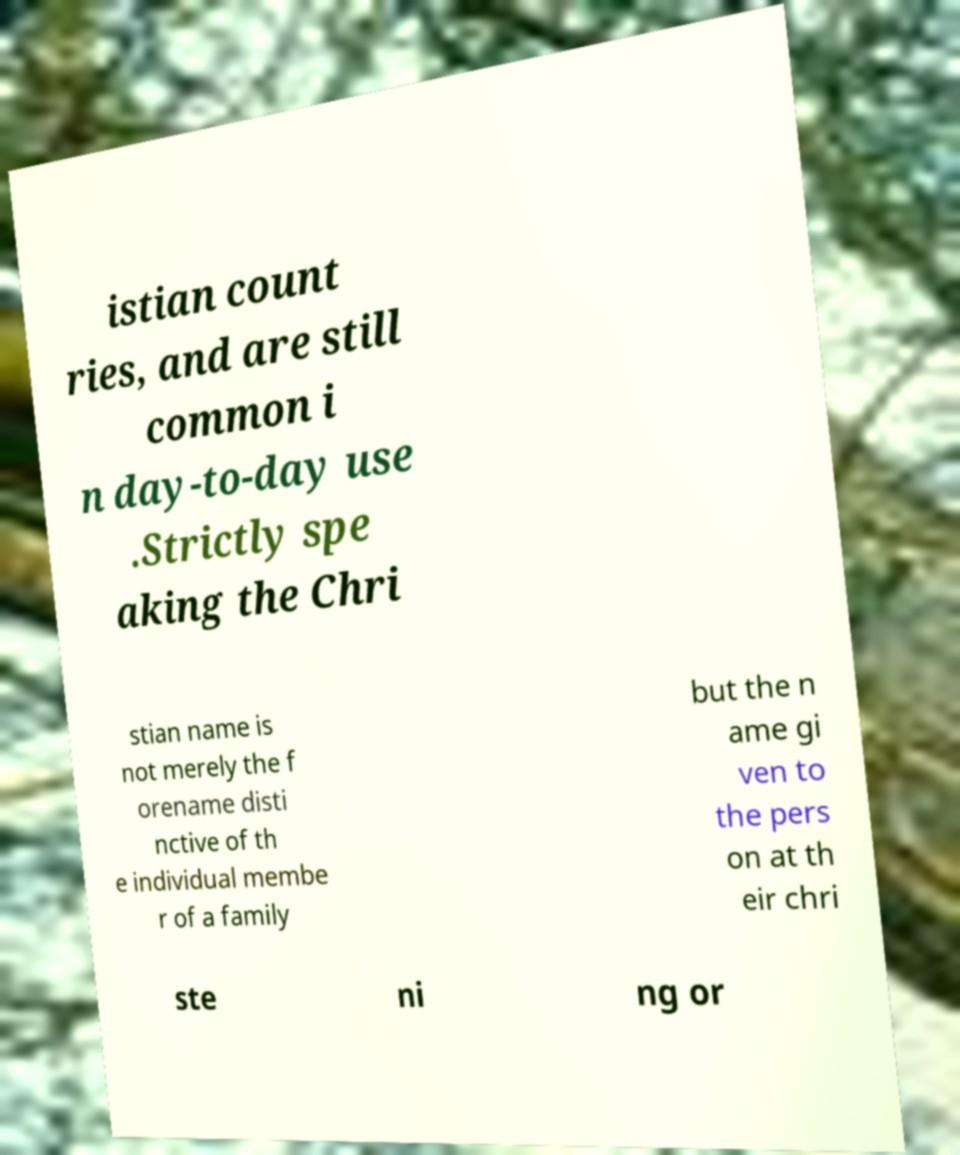What messages or text are displayed in this image? I need them in a readable, typed format. istian count ries, and are still common i n day-to-day use .Strictly spe aking the Chri stian name is not merely the f orename disti nctive of th e individual membe r of a family but the n ame gi ven to the pers on at th eir chri ste ni ng or 